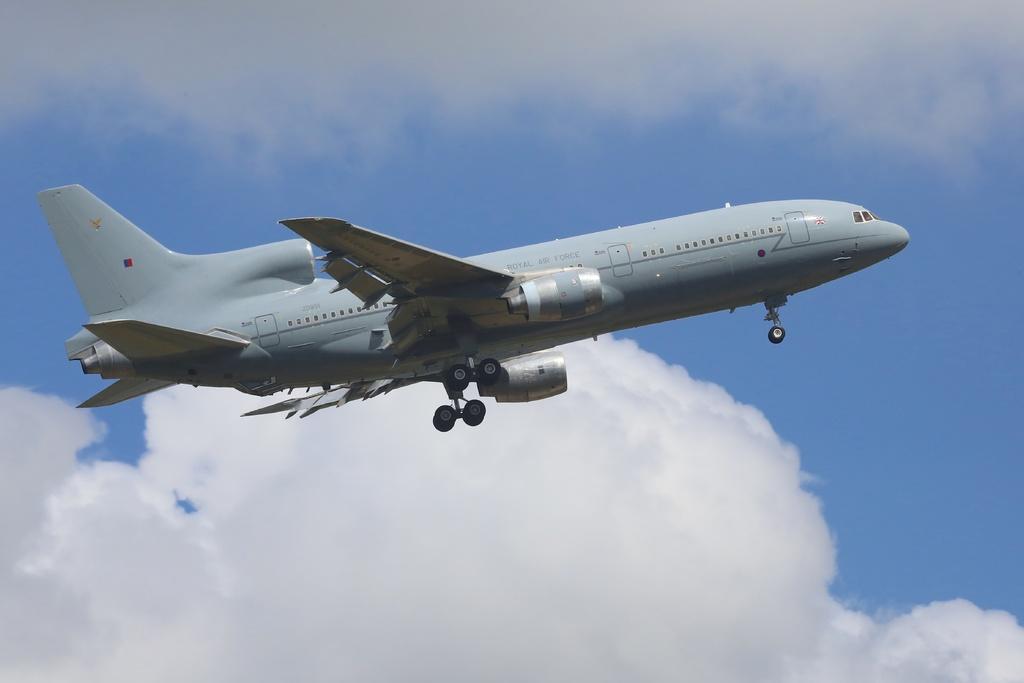Could you give a brief overview of what you see in this image? In this image I can see an aeroplane which is in grey color. I can see wheels. The sky is in blue and white color. 